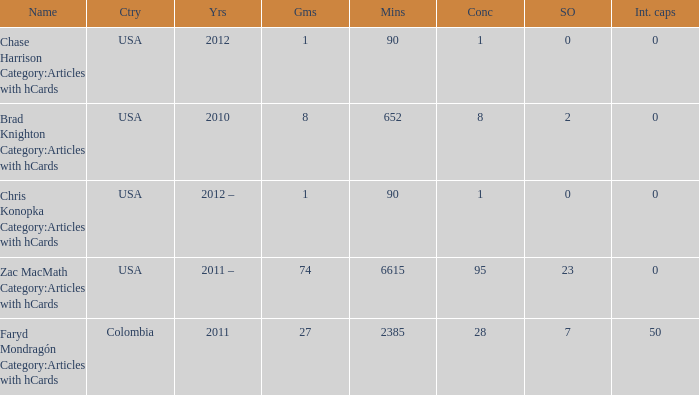When chase harrison category:articles with hcards is the name what is the year? 2012.0. 